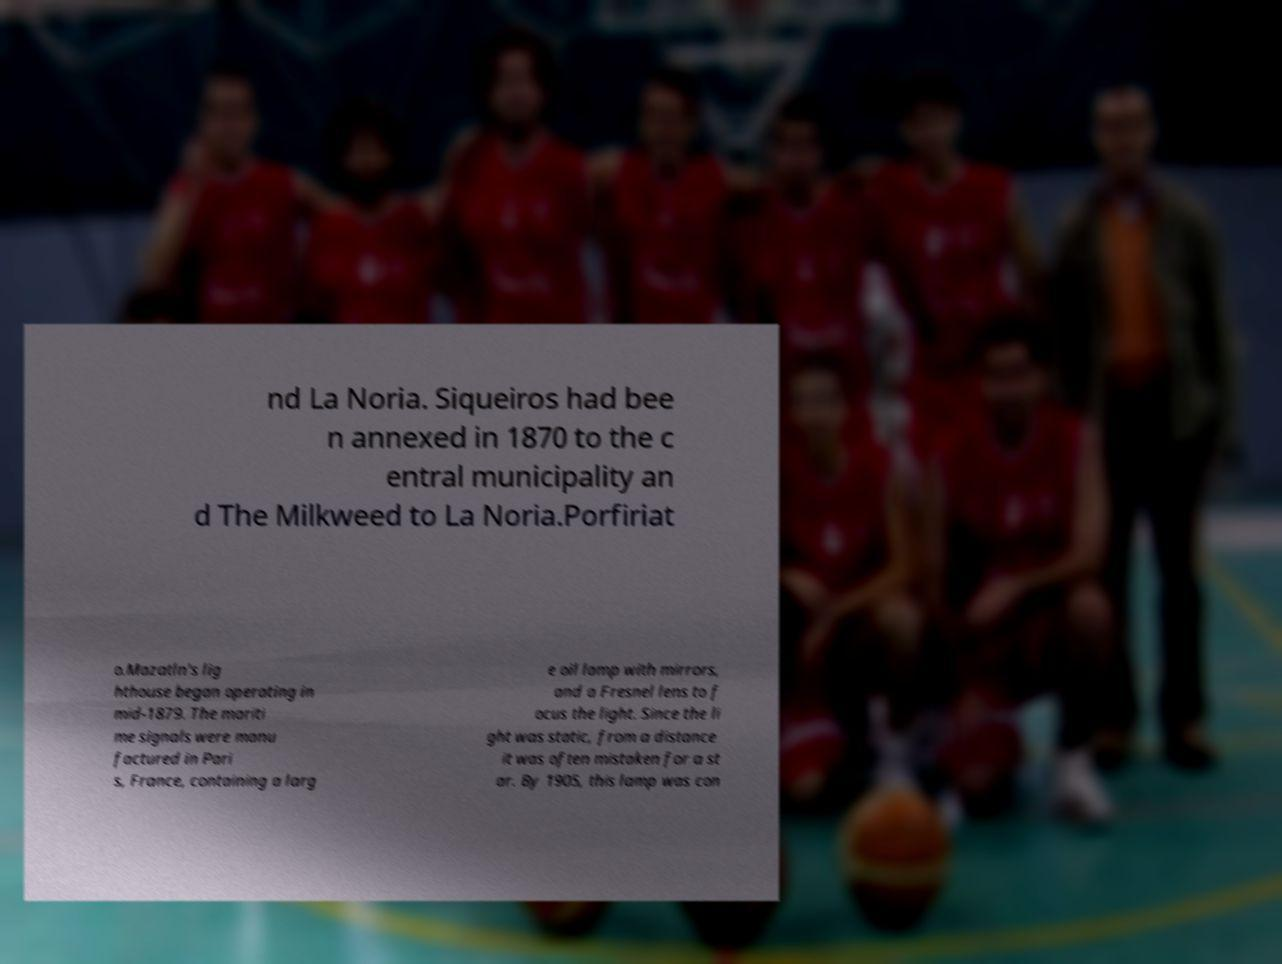For documentation purposes, I need the text within this image transcribed. Could you provide that? nd La Noria. Siqueiros had bee n annexed in 1870 to the c entral municipality an d The Milkweed to La Noria.Porfiriat o.Mazatln's lig hthouse began operating in mid-1879. The mariti me signals were manu factured in Pari s, France, containing a larg e oil lamp with mirrors, and a Fresnel lens to f ocus the light. Since the li ght was static, from a distance it was often mistaken for a st ar. By 1905, this lamp was con 